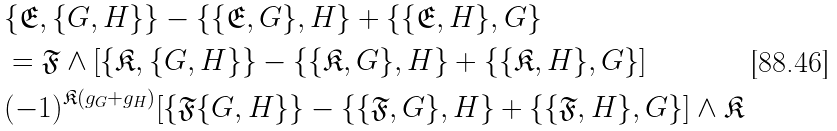Convert formula to latex. <formula><loc_0><loc_0><loc_500><loc_500>& \{ \mathfrak { E } , \{ G , H \} \} - \{ \{ \mathfrak { E } , G \} , H \} + \{ \{ \mathfrak { E } , H \} , G \} \\ & = \mathfrak { F } \wedge [ \{ \mathfrak { K } , \{ G , H \} \} - \{ \{ \mathfrak { K } , G \} , H \} + \{ \{ \mathfrak { K } , H \} , G \} ] \\ & ( - 1 ) ^ { \mathfrak { K } ( g _ { G } + g _ { H } ) } [ \{ \mathfrak { F } \{ G , H \} \} - \{ \{ \mathfrak { F } , G \} , H \} + \{ \{ \mathfrak { F } , H \} , G \} ] \wedge \mathfrak { K }</formula> 